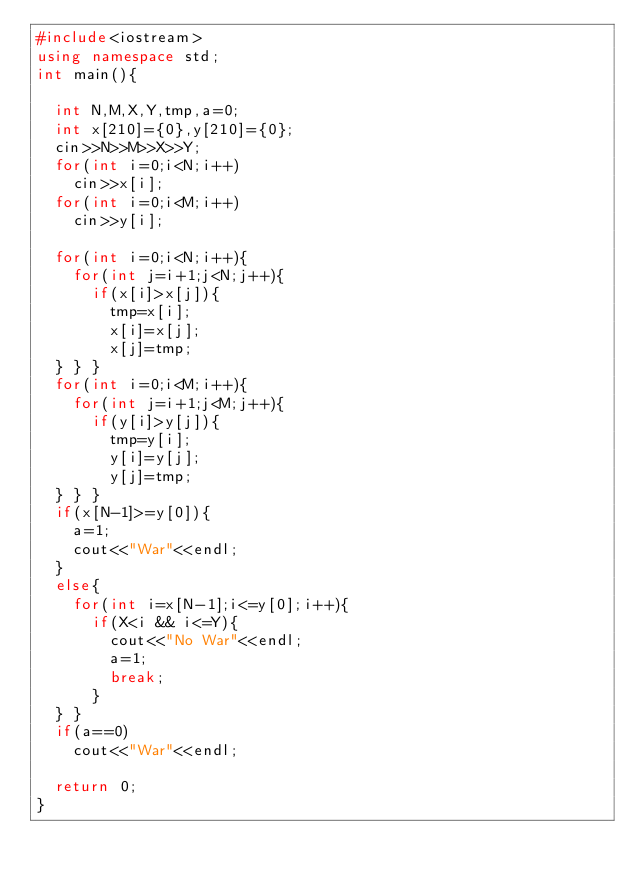<code> <loc_0><loc_0><loc_500><loc_500><_C++_>#include<iostream>
using namespace std;
int main(){

	int N,M,X,Y,tmp,a=0;
	int x[210]={0},y[210]={0};
	cin>>N>>M>>X>>Y;
	for(int i=0;i<N;i++)
		cin>>x[i];
	for(int i=0;i<M;i++)
		cin>>y[i];
	
	for(int i=0;i<N;i++){
		for(int j=i+1;j<N;j++){
			if(x[i]>x[j]){
				tmp=x[i];
				x[i]=x[j];
				x[j]=tmp;
	}	}	}
	for(int i=0;i<M;i++){
		for(int j=i+1;j<M;j++){
			if(y[i]>y[j]){
				tmp=y[i];
				y[i]=y[j];
				y[j]=tmp;
	}	}	}
	if(x[N-1]>=y[0]){
		a=1;
		cout<<"War"<<endl;
	}
	else{
		for(int i=x[N-1];i<=y[0];i++){
			if(X<i && i<=Y){
				cout<<"No War"<<endl;
				a=1;
				break;
			}
	}	}
	if(a==0)
		cout<<"War"<<endl;
	
	return 0;
}</code> 